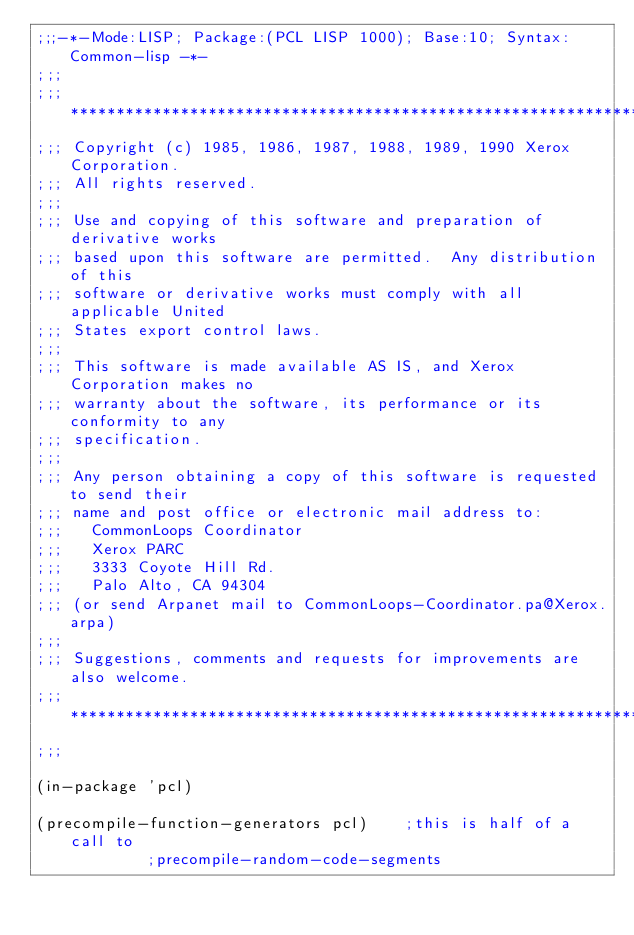<code> <loc_0><loc_0><loc_500><loc_500><_Lisp_>;;;-*-Mode:LISP; Package:(PCL LISP 1000); Base:10; Syntax:Common-lisp -*-
;;;
;;; *************************************************************************
;;; Copyright (c) 1985, 1986, 1987, 1988, 1989, 1990 Xerox Corporation.
;;; All rights reserved.
;;;
;;; Use and copying of this software and preparation of derivative works
;;; based upon this software are permitted.  Any distribution of this
;;; software or derivative works must comply with all applicable United
;;; States export control laws.
;;; 
;;; This software is made available AS IS, and Xerox Corporation makes no
;;; warranty about the software, its performance or its conformity to any
;;; specification.
;;; 
;;; Any person obtaining a copy of this software is requested to send their
;;; name and post office or electronic mail address to:
;;;   CommonLoops Coordinator
;;;   Xerox PARC
;;;   3333 Coyote Hill Rd.
;;;   Palo Alto, CA 94304
;;; (or send Arpanet mail to CommonLoops-Coordinator.pa@Xerox.arpa)
;;;
;;; Suggestions, comments and requests for improvements are also welcome.
;;; *************************************************************************
;;;

(in-package 'pcl)

(precompile-function-generators pcl)		;this is half of a call to
						;precompile-random-code-segments

</code> 